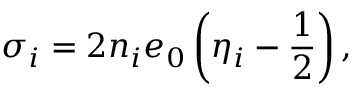<formula> <loc_0><loc_0><loc_500><loc_500>\sigma _ { i } = 2 n _ { i } e _ { 0 } \left ( \eta _ { i } - \frac { 1 } { 2 } \right ) ,</formula> 